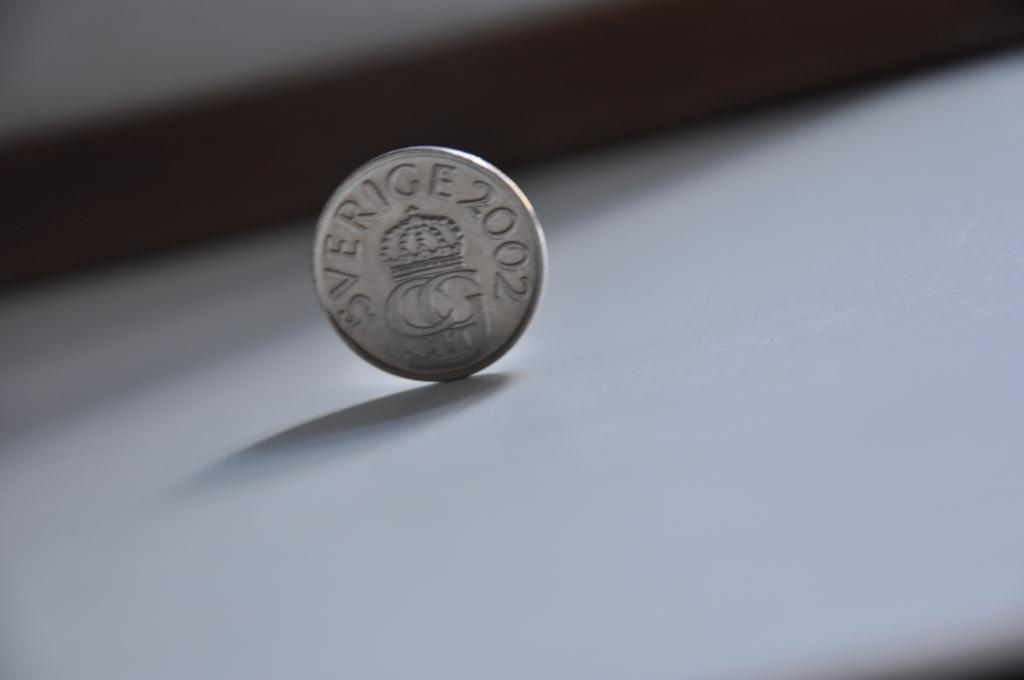<image>
Render a clear and concise summary of the photo. A silver coin is imprinted with the marking "sverige 2002" 